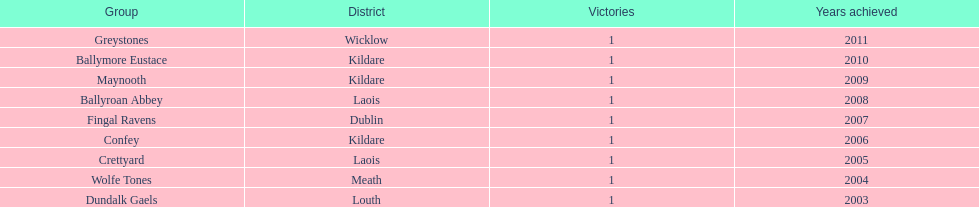Which is the first team from the chart Greystones. Could you help me parse every detail presented in this table? {'header': ['Group', 'District', 'Victories', 'Years achieved'], 'rows': [['Greystones', 'Wicklow', '1', '2011'], ['Ballymore Eustace', 'Kildare', '1', '2010'], ['Maynooth', 'Kildare', '1', '2009'], ['Ballyroan Abbey', 'Laois', '1', '2008'], ['Fingal Ravens', 'Dublin', '1', '2007'], ['Confey', 'Kildare', '1', '2006'], ['Crettyard', 'Laois', '1', '2005'], ['Wolfe Tones', 'Meath', '1', '2004'], ['Dundalk Gaels', 'Louth', '1', '2003']]} 